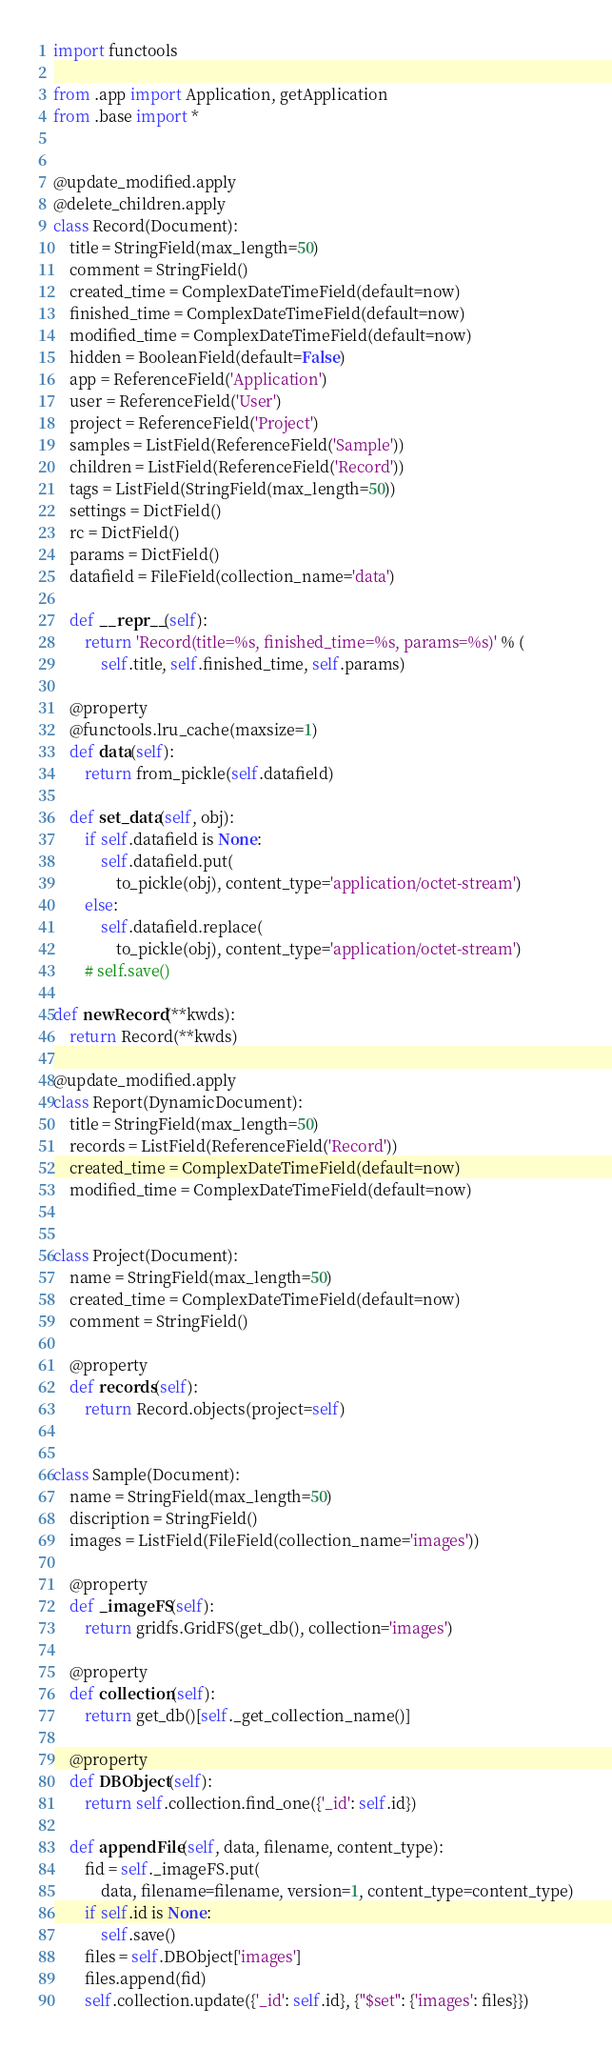Convert code to text. <code><loc_0><loc_0><loc_500><loc_500><_Python_>import functools

from .app import Application, getApplication
from .base import *


@update_modified.apply
@delete_children.apply
class Record(Document):
    title = StringField(max_length=50)
    comment = StringField()
    created_time = ComplexDateTimeField(default=now)
    finished_time = ComplexDateTimeField(default=now)
    modified_time = ComplexDateTimeField(default=now)
    hidden = BooleanField(default=False)
    app = ReferenceField('Application')
    user = ReferenceField('User')
    project = ReferenceField('Project')
    samples = ListField(ReferenceField('Sample'))
    children = ListField(ReferenceField('Record'))
    tags = ListField(StringField(max_length=50))
    settings = DictField()
    rc = DictField()
    params = DictField()
    datafield = FileField(collection_name='data')

    def __repr__(self):
        return 'Record(title=%s, finished_time=%s, params=%s)' % (
            self.title, self.finished_time, self.params)

    @property
    @functools.lru_cache(maxsize=1)
    def data(self):
        return from_pickle(self.datafield)

    def set_data(self, obj):
        if self.datafield is None:
            self.datafield.put(
                to_pickle(obj), content_type='application/octet-stream')
        else:
            self.datafield.replace(
                to_pickle(obj), content_type='application/octet-stream')
        # self.save()

def newRecord(**kwds):
    return Record(**kwds)

@update_modified.apply
class Report(DynamicDocument):
    title = StringField(max_length=50)
    records = ListField(ReferenceField('Record'))
    created_time = ComplexDateTimeField(default=now)
    modified_time = ComplexDateTimeField(default=now)


class Project(Document):
    name = StringField(max_length=50)
    created_time = ComplexDateTimeField(default=now)
    comment = StringField()

    @property
    def records(self):
        return Record.objects(project=self)


class Sample(Document):
    name = StringField(max_length=50)
    discription = StringField()
    images = ListField(FileField(collection_name='images'))

    @property
    def _imageFS(self):
        return gridfs.GridFS(get_db(), collection='images')

    @property
    def collection(self):
        return get_db()[self._get_collection_name()]

    @property
    def DBObject(self):
        return self.collection.find_one({'_id': self.id})

    def appendFile(self, data, filename, content_type):
        fid = self._imageFS.put(
            data, filename=filename, version=1, content_type=content_type)
        if self.id is None:
            self.save()
        files = self.DBObject['images']
        files.append(fid)
        self.collection.update({'_id': self.id}, {"$set": {'images': files}})
</code> 